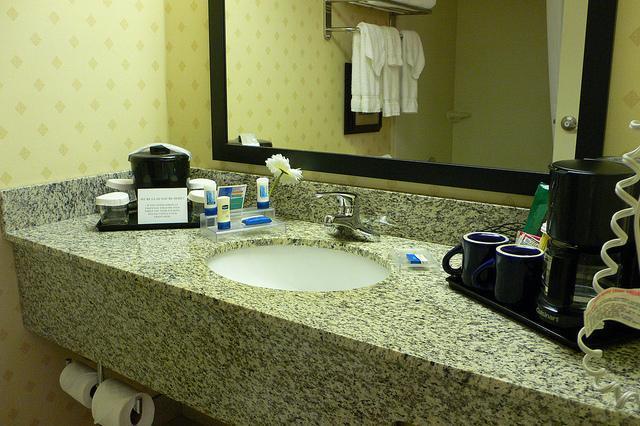How many rolls of toilet paper are pictured?
Give a very brief answer. 2. How many handles are on the faucet?
Give a very brief answer. 1. How many bottles of wine are there?
Give a very brief answer. 0. 